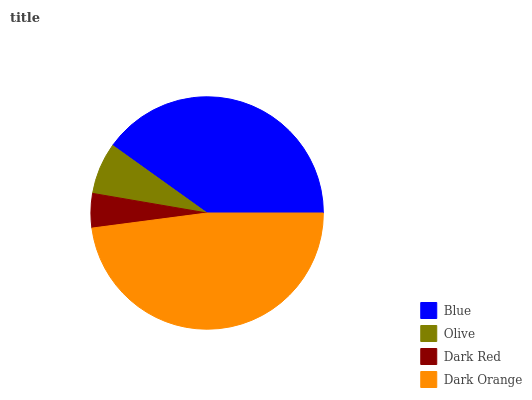Is Dark Red the minimum?
Answer yes or no. Yes. Is Dark Orange the maximum?
Answer yes or no. Yes. Is Olive the minimum?
Answer yes or no. No. Is Olive the maximum?
Answer yes or no. No. Is Blue greater than Olive?
Answer yes or no. Yes. Is Olive less than Blue?
Answer yes or no. Yes. Is Olive greater than Blue?
Answer yes or no. No. Is Blue less than Olive?
Answer yes or no. No. Is Blue the high median?
Answer yes or no. Yes. Is Olive the low median?
Answer yes or no. Yes. Is Olive the high median?
Answer yes or no. No. Is Dark Orange the low median?
Answer yes or no. No. 